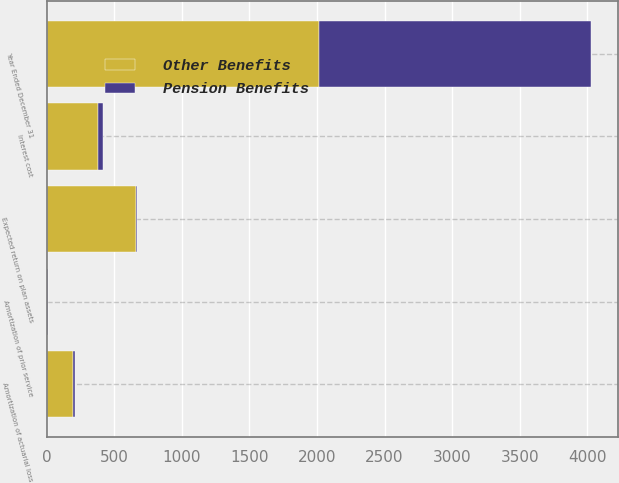Convert chart. <chart><loc_0><loc_0><loc_500><loc_500><stacked_bar_chart><ecel><fcel>Year Ended December 31<fcel>Interest cost<fcel>Expected return on plan assets<fcel>Amortization of prior service<fcel>Amortization of actuarial loss<nl><fcel>Other Benefits<fcel>2013<fcel>378<fcel>659<fcel>2<fcel>197<nl><fcel>Pension Benefits<fcel>2013<fcel>42<fcel>9<fcel>10<fcel>13<nl></chart> 